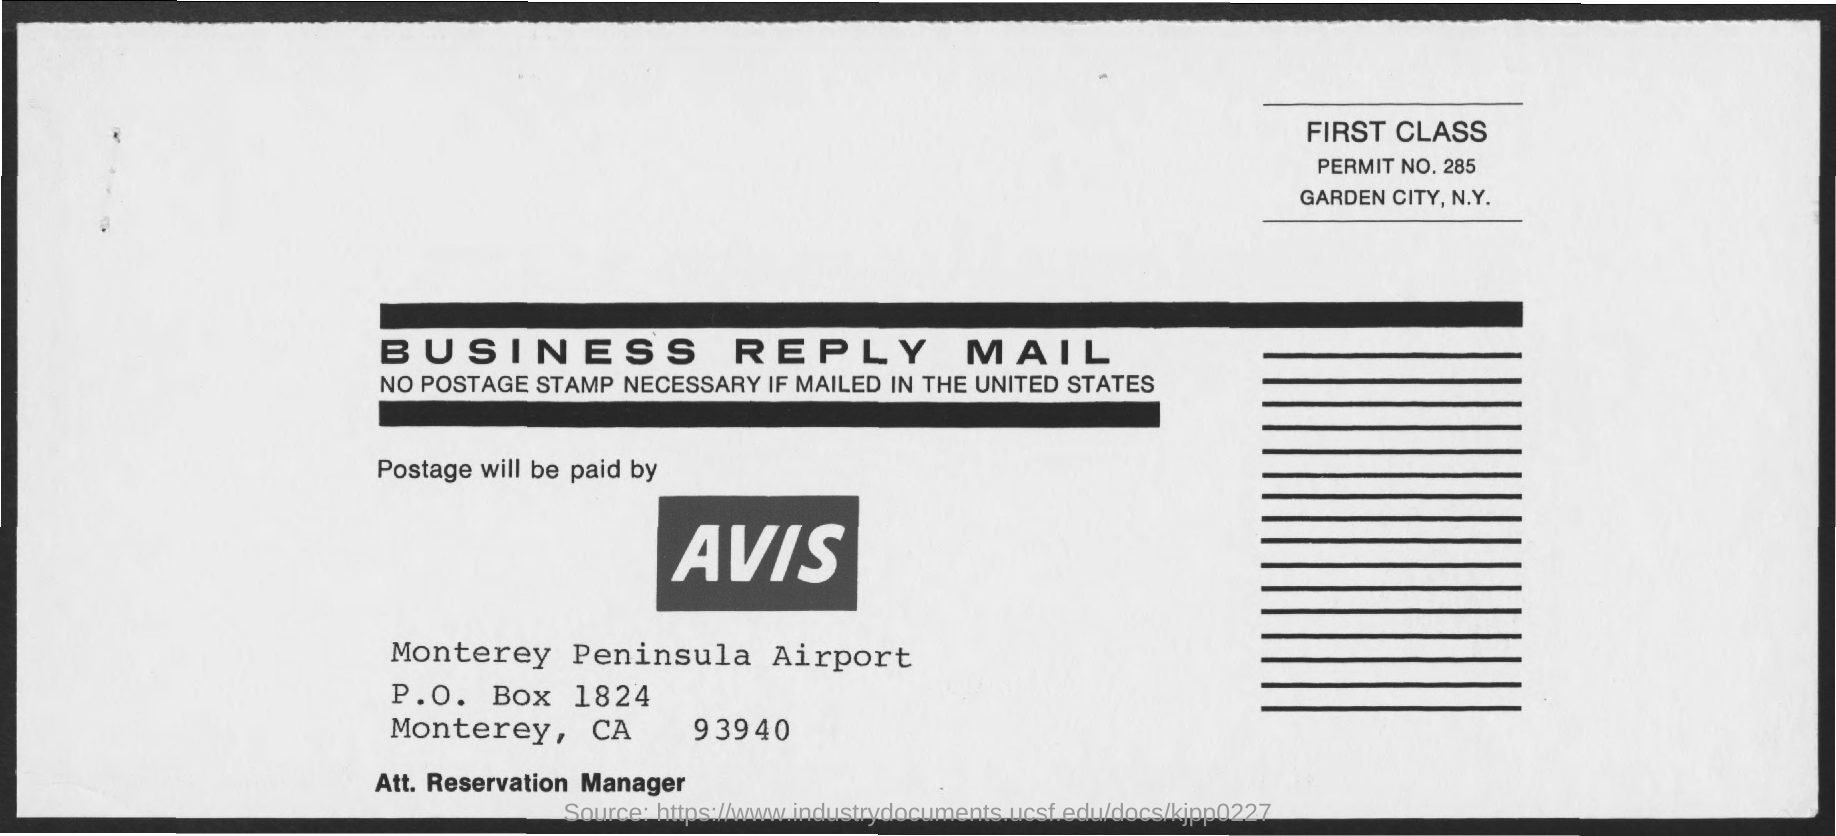List a handful of essential elements in this visual. The permit number mentioned is 285. The P.O. box number mentioned is 1824. The class mentioned is a first-class object. The postage will be paid by Avis. The Monterey Peninsula Airport is named after the airport. 